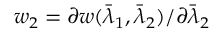Convert formula to latex. <formula><loc_0><loc_0><loc_500><loc_500>w _ { 2 } = \partial w ( \bar { \lambda } _ { 1 } , \bar { \lambda } _ { 2 } ) / \partial \bar { \lambda } _ { 2 }</formula> 